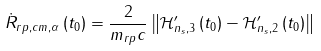<formula> <loc_0><loc_0><loc_500><loc_500>\dot { R } _ { r p , c m , \alpha } \left ( t _ { 0 } \right ) & = \frac { 2 } { m _ { r p } c } \left \| \mathcal { H } ^ { \prime } _ { n _ { s } , 3 } \left ( t _ { 0 } \right ) - \mathcal { H } ^ { \prime } _ { n _ { s } , 2 } \left ( t _ { 0 } \right ) \right \|</formula> 